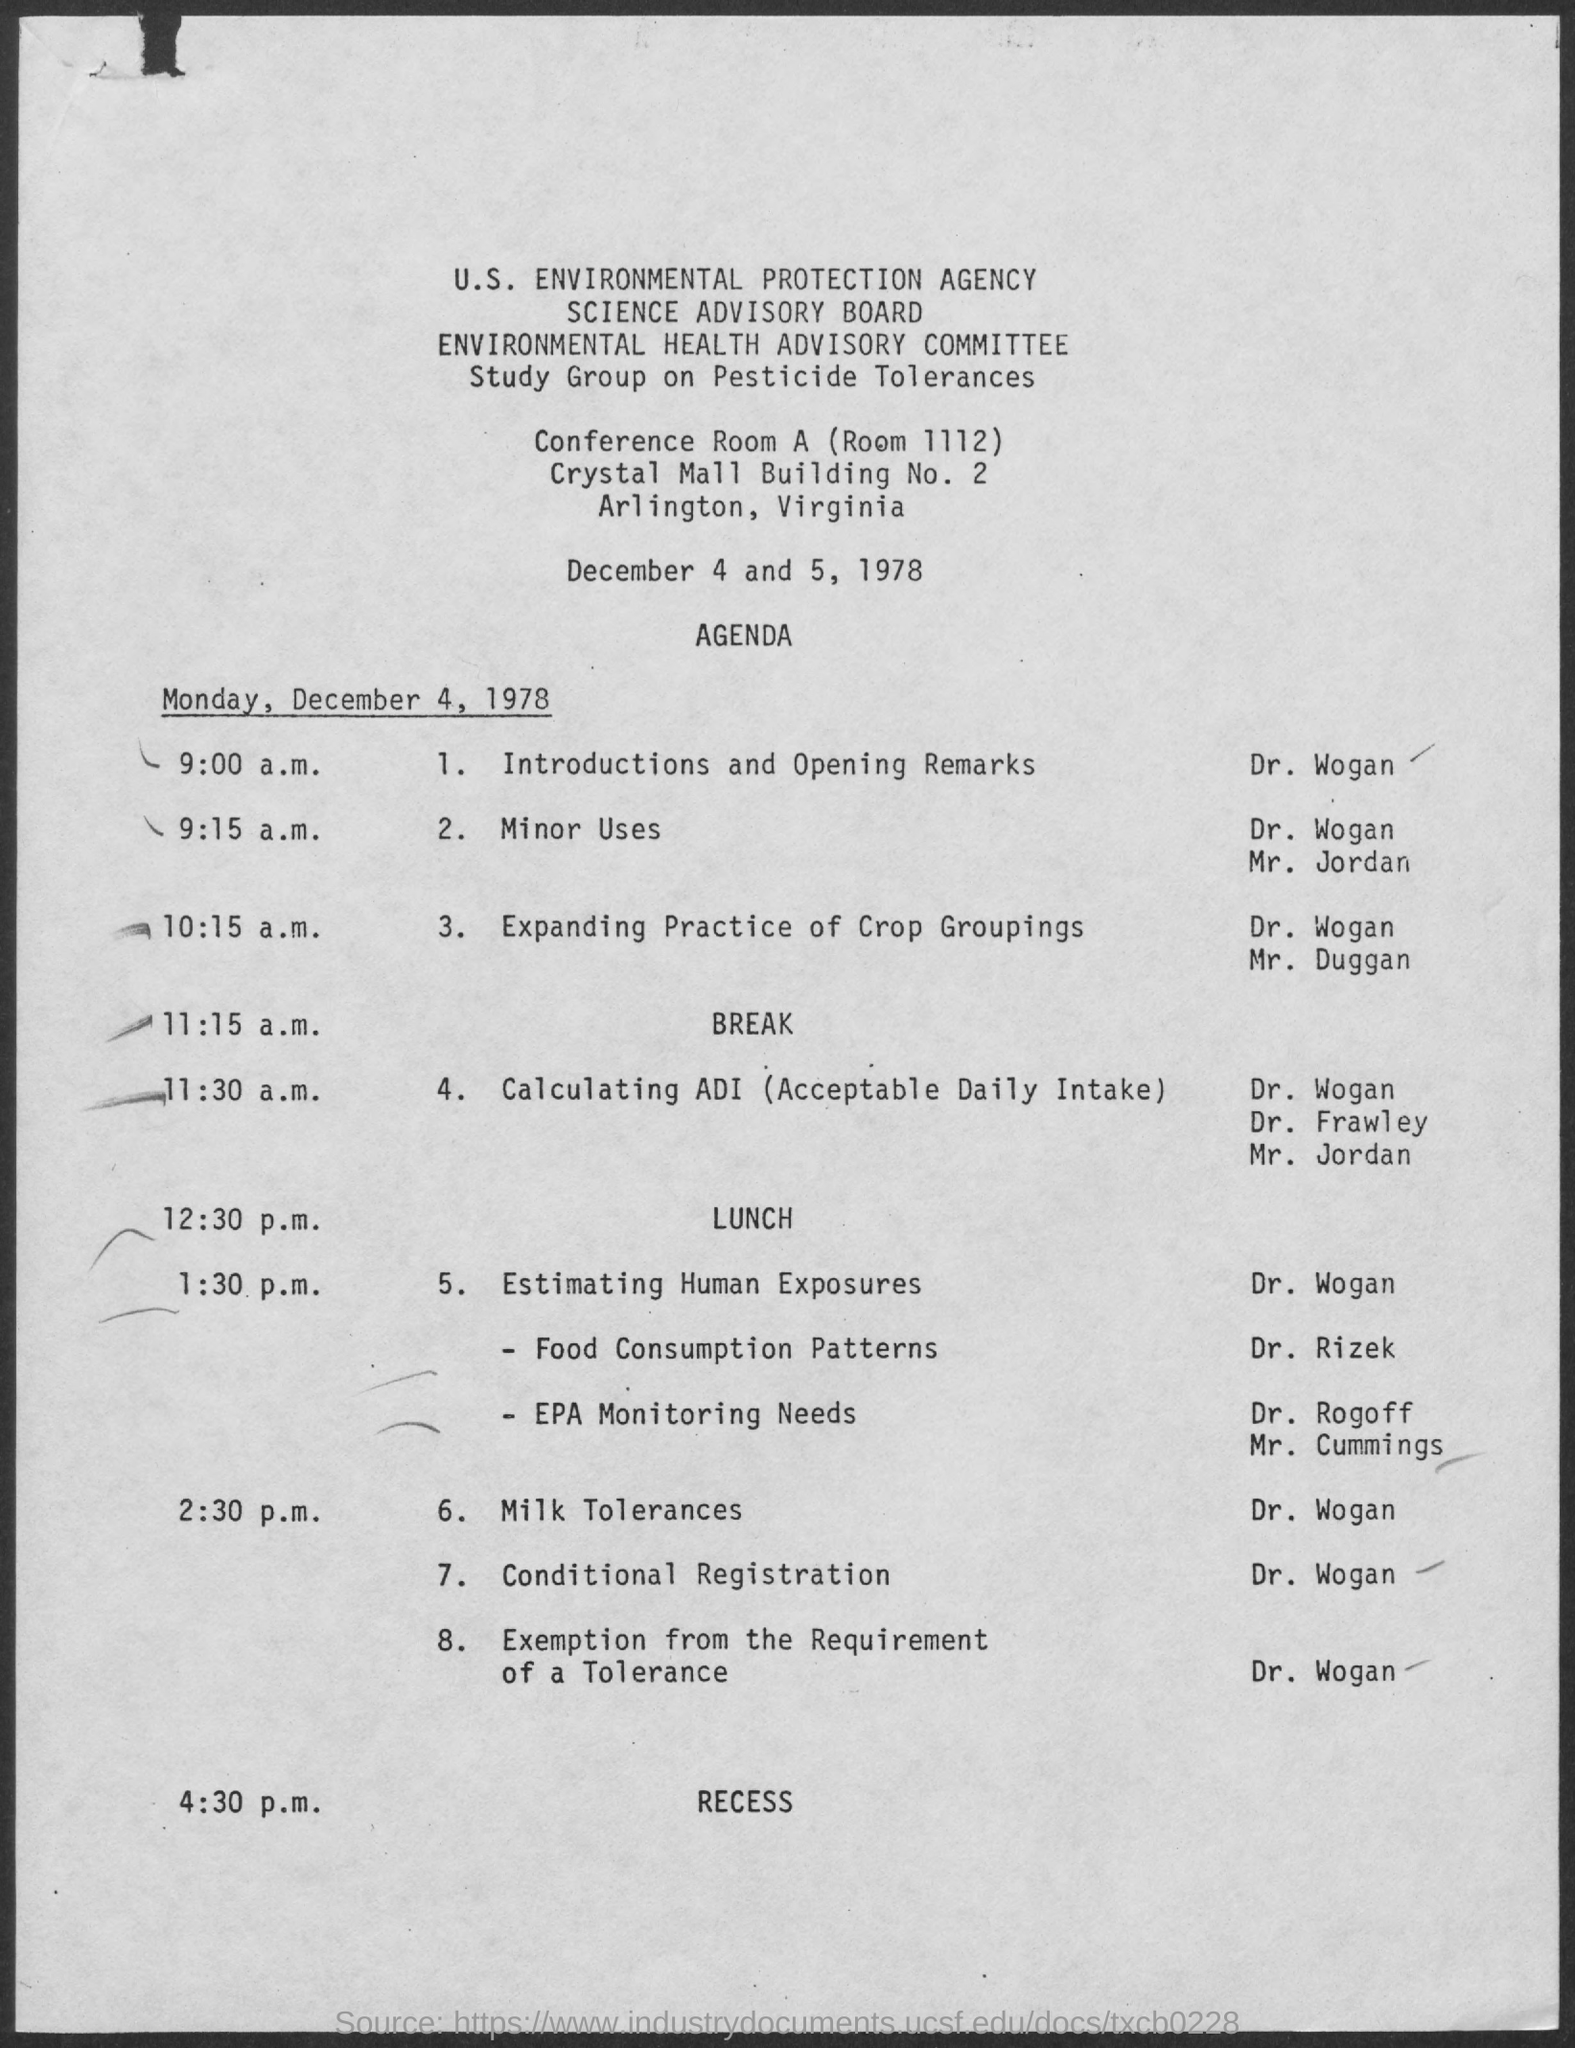What is the full form of ADI?
Provide a short and direct response. Acceptable Daily Intake. What is the first topic after lunch?
Provide a succinct answer. 5. estimating human exposures. 